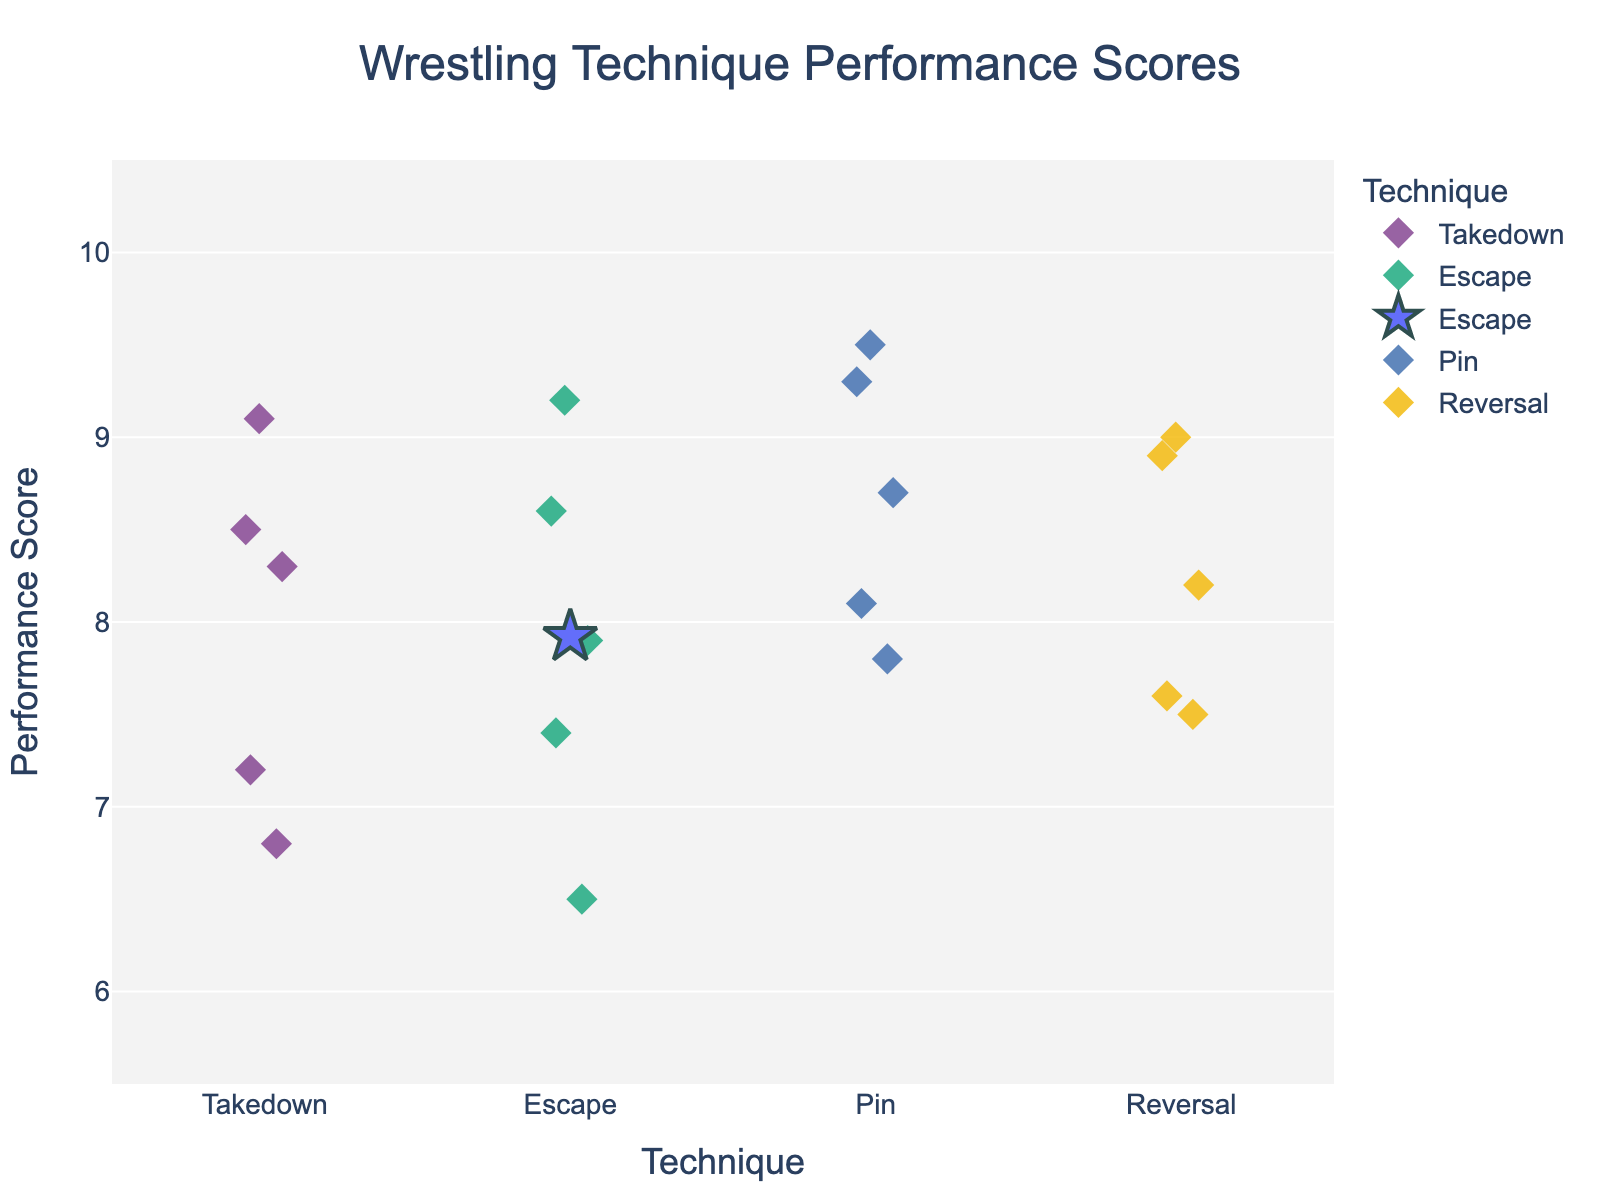What's the title of the plot? The title of the plot is text at the top that describes what the plot is about.
Answer: Wrestling Technique Performance Scores Which technique has the highest score? To find the technique with the highest score, look for the highest data point on the y-axis and check its corresponding x-axis label.
Answer: Escape How many data points are there for the 'Takedown' technique? Count the number of markers in the 'Takedown' category on the x-axis.
Answer: 5 What is the mean performance score for the 'Pin' technique? The mean score for each technique is indicated by the star-shaped markers. Look at the y-axis value of the star in the 'Pin' category.
Answer: ~8.68 What is the lowest score for the 'Reversal' technique? Identify the lowest point within the 'Reversal' category on the y-axis.
Answer: 7.5 Which technique has the most consistent performance scores? Consistency can be inferred from the spread or dispersion of the markers for each technique. The technique with markers closest together has the most consistent scores.
Answer: Pin How does the mean performance score for 'Escape' compare to 'Takedown'? Look at the positions of the star markers for both 'Escape' and 'Takedown' on the y-axis and compare their heights.
Answer: Escape is higher What is the range of scores for the 'Reversal' technique? Subtract the lowest score (7.5) from the highest score (9.0) for the 'Reversal' category.
Answer: 1.5 Which technique has the highest mean score? Identify the highest star marker on the y-axis and check its corresponding x-axis label.
Answer: Reversal Is there any overlap in scores between 'Takedown' and 'Escape'? Look for any y-axis values that are common between the 'Takedown' and 'Escape' categories.
Answer: Yes 